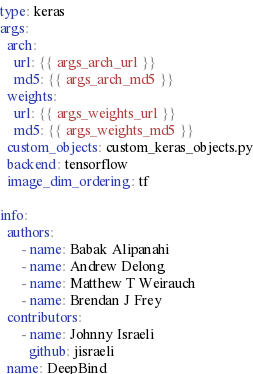<code> <loc_0><loc_0><loc_500><loc_500><_YAML_>type: keras
args:
  arch:
    url: {{ args_arch_url }}
    md5: {{ args_arch_md5 }}
  weights:
    url: {{ args_weights_url }}
    md5: {{ args_weights_md5 }}
  custom_objects: custom_keras_objects.py
  backend: tensorflow
  image_dim_ordering: tf

info:
  authors:
      - name: Babak Alipanahi
      - name: Andrew Delong
      - name: Matthew T Weirauch
      - name: Brendan J Frey
  contributors:
      - name: Johnny Israeli
        github: jisraeli
  name: DeepBind</code> 